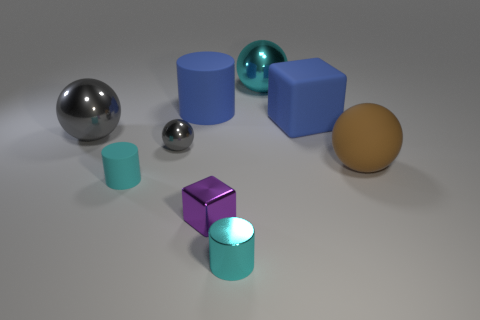Is there any other thing that is made of the same material as the tiny gray thing?
Give a very brief answer. Yes. Does the large cube have the same color as the tiny cube on the right side of the tiny shiny ball?
Your response must be concise. No. What shape is the purple shiny thing?
Make the answer very short. Cube. There is a block in front of the big blue block that is behind the cyan thing that is left of the blue matte cylinder; how big is it?
Ensure brevity in your answer.  Small. How many other objects are there of the same shape as the large brown object?
Ensure brevity in your answer.  3. Is the shape of the big blue rubber object to the right of the cyan shiny cylinder the same as the metal thing that is behind the blue matte cylinder?
Your answer should be very brief. No. What number of balls are big blue things or small objects?
Your answer should be compact. 1. What material is the block behind the big ball right of the block that is behind the big brown ball?
Ensure brevity in your answer.  Rubber. How many other things are the same size as the rubber block?
Offer a very short reply. 4. What is the size of the object that is the same color as the tiny shiny ball?
Give a very brief answer. Large. 